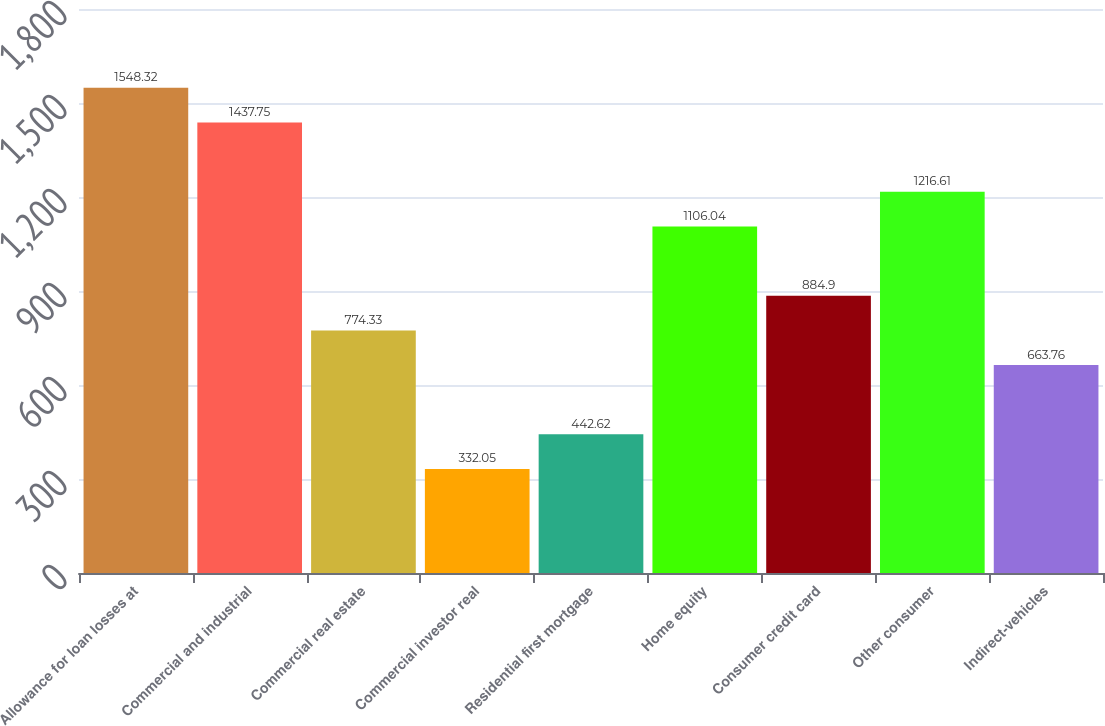Convert chart. <chart><loc_0><loc_0><loc_500><loc_500><bar_chart><fcel>Allowance for loan losses at<fcel>Commercial and industrial<fcel>Commercial real estate<fcel>Commercial investor real<fcel>Residential first mortgage<fcel>Home equity<fcel>Consumer credit card<fcel>Other consumer<fcel>Indirect-vehicles<nl><fcel>1548.32<fcel>1437.75<fcel>774.33<fcel>332.05<fcel>442.62<fcel>1106.04<fcel>884.9<fcel>1216.61<fcel>663.76<nl></chart> 